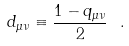<formula> <loc_0><loc_0><loc_500><loc_500>d _ { \mu \nu } \equiv \frac { 1 - q _ { \mu \nu } } { 2 } \ .</formula> 